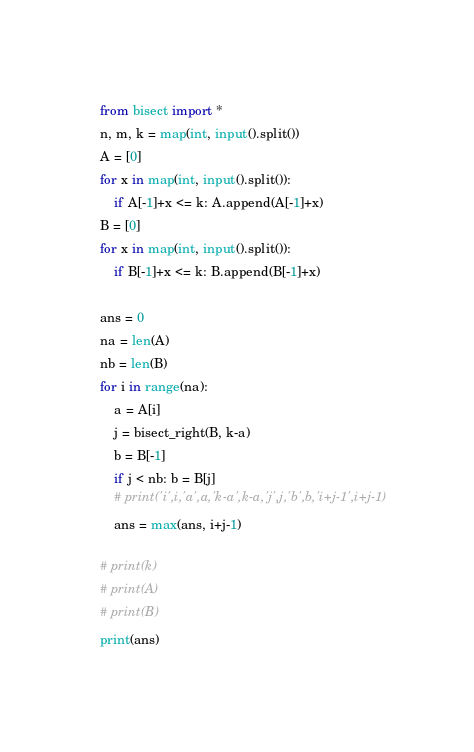Convert code to text. <code><loc_0><loc_0><loc_500><loc_500><_Python_>from bisect import *
n, m, k = map(int, input().split())
A = [0]
for x in map(int, input().split()):
    if A[-1]+x <= k: A.append(A[-1]+x)
B = [0]
for x in map(int, input().split()):
    if B[-1]+x <= k: B.append(B[-1]+x)

ans = 0
na = len(A)
nb = len(B)
for i in range(na):
    a = A[i]
    j = bisect_right(B, k-a)
    b = B[-1]
    if j < nb: b = B[j]
    # print('i',i,'a',a,'k-a',k-a,'j',j,'b',b,'i+j-1',i+j-1)
    ans = max(ans, i+j-1)

# print(k)
# print(A)
# print(B)
print(ans)
</code> 